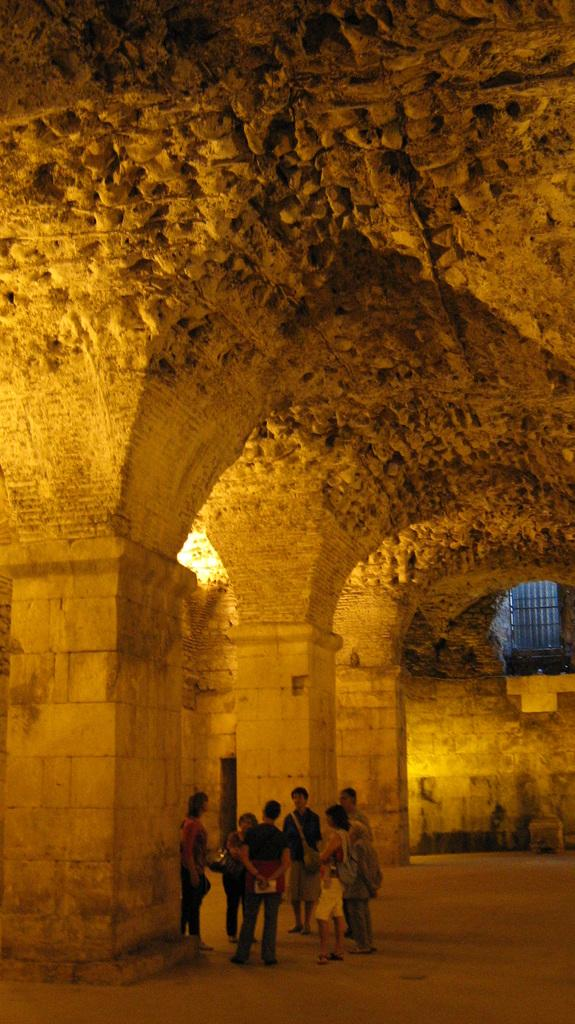What type of structure is present in the image? There is a building in the image. Can you describe the people in the image? There are people standing in the image. What is the profit margin of the building in the image? There is no information about the profit margin of the building in the image, as it does not provide any financial details. 